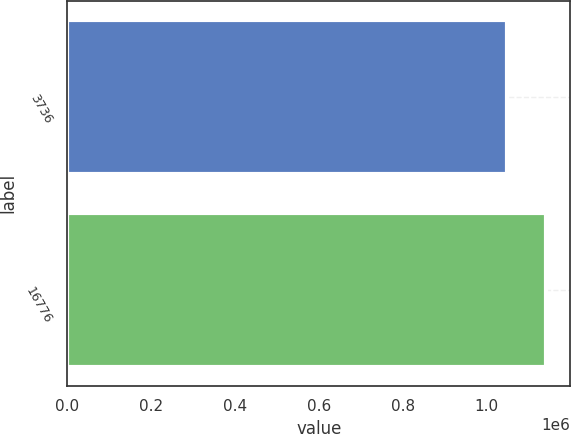Convert chart. <chart><loc_0><loc_0><loc_500><loc_500><bar_chart><fcel>3736<fcel>16776<nl><fcel>1.04893e+06<fcel>1.14197e+06<nl></chart> 